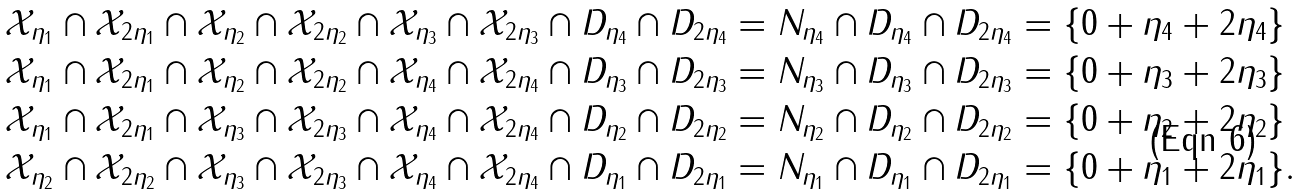Convert formula to latex. <formula><loc_0><loc_0><loc_500><loc_500>\mathcal { X } _ { \eta _ { 1 } } \cap \mathcal { X } _ { 2 \eta _ { 1 } } \cap \mathcal { X } _ { \eta _ { 2 } } \cap \mathcal { X } _ { 2 \eta _ { 2 } } \cap \mathcal { X } _ { \eta _ { 3 } } \cap \mathcal { X } _ { 2 \eta _ { 3 } } \cap D _ { \eta _ { 4 } } \cap D _ { 2 \eta _ { 4 } } & = N _ { \eta _ { 4 } } \cap D _ { \eta _ { 4 } } \cap D _ { 2 \eta _ { 4 } } = \{ 0 + \eta _ { 4 } + 2 \eta _ { 4 } \} \\ \mathcal { X } _ { \eta _ { 1 } } \cap \mathcal { X } _ { 2 \eta _ { 1 } } \cap \mathcal { X } _ { \eta _ { 2 } } \cap \mathcal { X } _ { 2 \eta _ { 2 } } \cap \mathcal { X } _ { \eta _ { 4 } } \cap \mathcal { X } _ { 2 \eta _ { 4 } } \cap D _ { \eta _ { 3 } } \cap D _ { 2 \eta _ { 3 } } & = N _ { \eta _ { 3 } } \cap D _ { \eta _ { 3 } } \cap D _ { 2 \eta _ { 3 } } = \{ 0 + \eta _ { 3 } + 2 \eta _ { 3 } \} \\ \mathcal { X } _ { \eta _ { 1 } } \cap \mathcal { X } _ { 2 \eta _ { 1 } } \cap \mathcal { X } _ { \eta _ { 3 } } \cap \mathcal { X } _ { 2 \eta _ { 3 } } \cap \mathcal { X } _ { \eta _ { 4 } } \cap \mathcal { X } _ { 2 \eta _ { 4 } } \cap D _ { \eta _ { 2 } } \cap D _ { 2 \eta _ { 2 } } & = N _ { \eta _ { 2 } } \cap D _ { \eta _ { 2 } } \cap D _ { 2 \eta _ { 2 } } = \{ 0 + \eta _ { 2 } + 2 \eta _ { 2 } \} \\ \mathcal { X } _ { \eta _ { 2 } } \cap \mathcal { X } _ { 2 \eta _ { 2 } } \cap \mathcal { X } _ { \eta _ { 3 } } \cap \mathcal { X } _ { 2 \eta _ { 3 } } \cap \mathcal { X } _ { \eta _ { 4 } } \cap \mathcal { X } _ { 2 \eta _ { 4 } } \cap D _ { \eta _ { 1 } } \cap D _ { 2 \eta _ { 1 } } & = N _ { \eta _ { 1 } } \cap D _ { \eta _ { 1 } } \cap D _ { 2 \eta _ { 1 } } = \{ 0 + \eta _ { 1 } + 2 \eta _ { 1 } \} .</formula> 